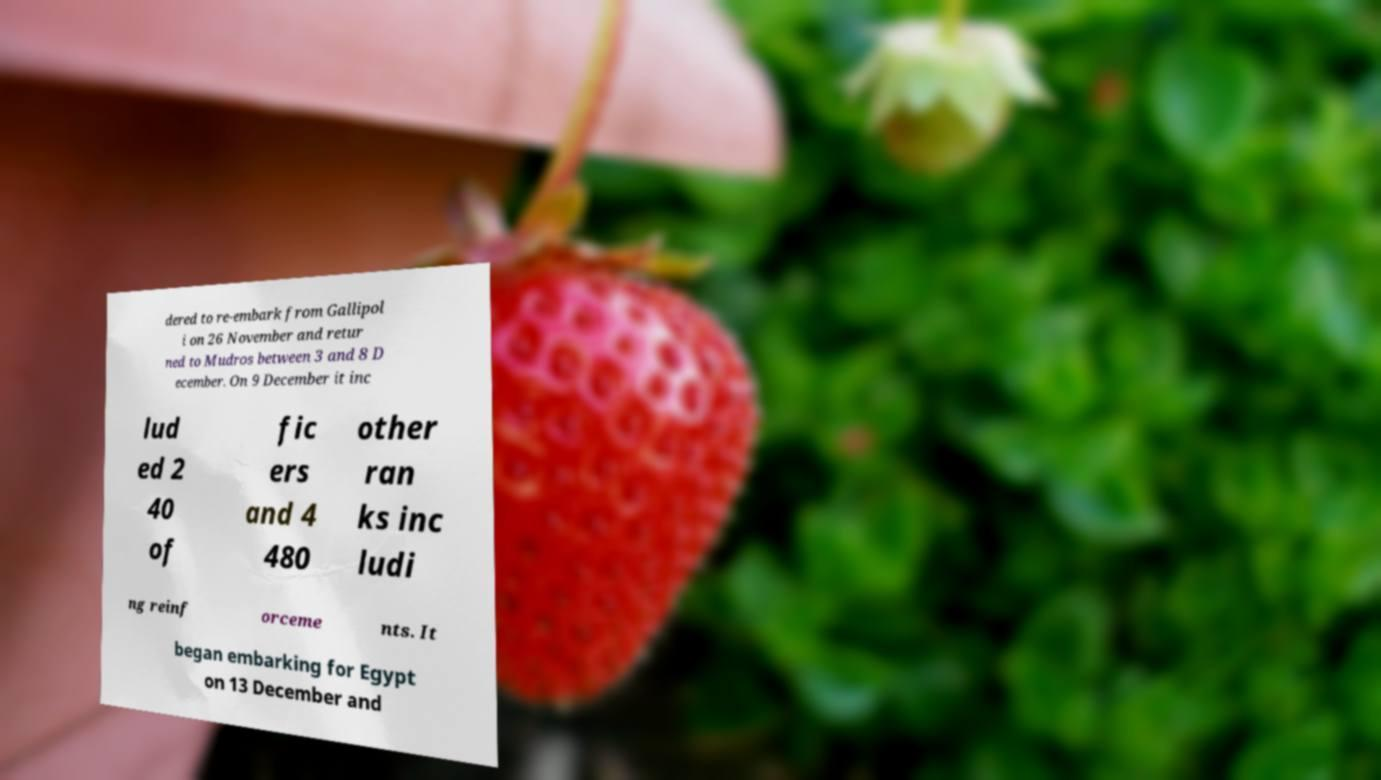Could you extract and type out the text from this image? dered to re-embark from Gallipol i on 26 November and retur ned to Mudros between 3 and 8 D ecember. On 9 December it inc lud ed 2 40 of fic ers and 4 480 other ran ks inc ludi ng reinf orceme nts. It began embarking for Egypt on 13 December and 